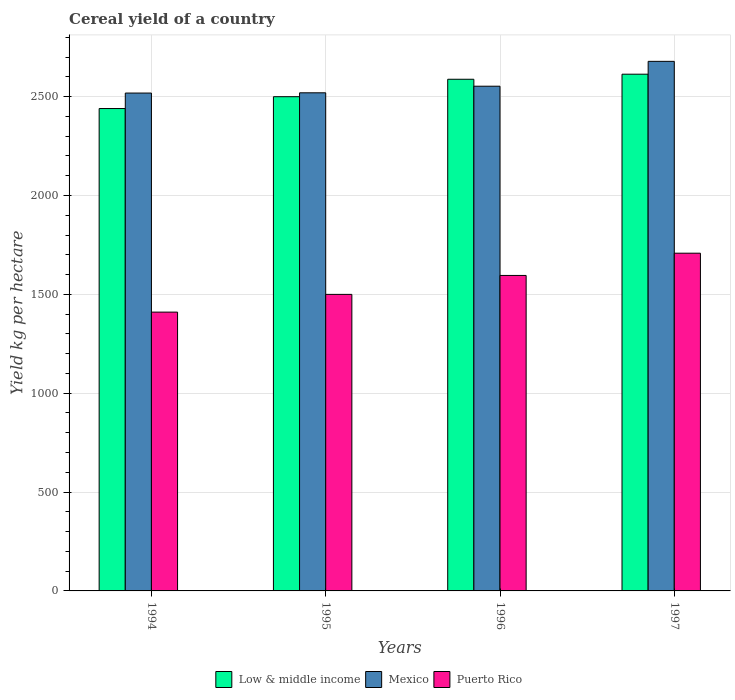How many different coloured bars are there?
Make the answer very short. 3. Are the number of bars per tick equal to the number of legend labels?
Make the answer very short. Yes. How many bars are there on the 2nd tick from the right?
Ensure brevity in your answer.  3. What is the label of the 2nd group of bars from the left?
Keep it short and to the point. 1995. In how many cases, is the number of bars for a given year not equal to the number of legend labels?
Keep it short and to the point. 0. What is the total cereal yield in Puerto Rico in 1995?
Ensure brevity in your answer.  1500. Across all years, what is the maximum total cereal yield in Puerto Rico?
Your answer should be compact. 1708.33. Across all years, what is the minimum total cereal yield in Puerto Rico?
Make the answer very short. 1410.26. What is the total total cereal yield in Low & middle income in the graph?
Make the answer very short. 1.01e+04. What is the difference between the total cereal yield in Mexico in 1995 and that in 1996?
Offer a terse response. -33.29. What is the difference between the total cereal yield in Mexico in 1996 and the total cereal yield in Puerto Rico in 1994?
Ensure brevity in your answer.  1142.67. What is the average total cereal yield in Puerto Rico per year?
Ensure brevity in your answer.  1553.58. In the year 1996, what is the difference between the total cereal yield in Puerto Rico and total cereal yield in Low & middle income?
Your answer should be very brief. -992.38. In how many years, is the total cereal yield in Puerto Rico greater than 400 kg per hectare?
Keep it short and to the point. 4. What is the ratio of the total cereal yield in Low & middle income in 1995 to that in 1996?
Your answer should be very brief. 0.97. What is the difference between the highest and the second highest total cereal yield in Mexico?
Your response must be concise. 125.77. What is the difference between the highest and the lowest total cereal yield in Low & middle income?
Your answer should be very brief. 173.73. In how many years, is the total cereal yield in Mexico greater than the average total cereal yield in Mexico taken over all years?
Give a very brief answer. 1. Is the sum of the total cereal yield in Low & middle income in 1994 and 1995 greater than the maximum total cereal yield in Mexico across all years?
Make the answer very short. Yes. What does the 3rd bar from the left in 1996 represents?
Provide a succinct answer. Puerto Rico. Is it the case that in every year, the sum of the total cereal yield in Mexico and total cereal yield in Low & middle income is greater than the total cereal yield in Puerto Rico?
Offer a very short reply. Yes. How many years are there in the graph?
Your answer should be compact. 4. Are the values on the major ticks of Y-axis written in scientific E-notation?
Ensure brevity in your answer.  No. Does the graph contain any zero values?
Provide a succinct answer. No. Does the graph contain grids?
Make the answer very short. Yes. What is the title of the graph?
Your answer should be compact. Cereal yield of a country. Does "Bosnia and Herzegovina" appear as one of the legend labels in the graph?
Offer a very short reply. No. What is the label or title of the Y-axis?
Ensure brevity in your answer.  Yield kg per hectare. What is the Yield kg per hectare of Low & middle income in 1994?
Make the answer very short. 2440. What is the Yield kg per hectare in Mexico in 1994?
Provide a short and direct response. 2518.31. What is the Yield kg per hectare in Puerto Rico in 1994?
Your answer should be compact. 1410.26. What is the Yield kg per hectare of Low & middle income in 1995?
Your answer should be very brief. 2499.92. What is the Yield kg per hectare of Mexico in 1995?
Your answer should be very brief. 2519.63. What is the Yield kg per hectare in Puerto Rico in 1995?
Offer a terse response. 1500. What is the Yield kg per hectare in Low & middle income in 1996?
Ensure brevity in your answer.  2588.12. What is the Yield kg per hectare of Mexico in 1996?
Provide a short and direct response. 2552.93. What is the Yield kg per hectare in Puerto Rico in 1996?
Your answer should be compact. 1595.74. What is the Yield kg per hectare in Low & middle income in 1997?
Provide a succinct answer. 2613.73. What is the Yield kg per hectare of Mexico in 1997?
Offer a terse response. 2678.7. What is the Yield kg per hectare of Puerto Rico in 1997?
Your answer should be very brief. 1708.33. Across all years, what is the maximum Yield kg per hectare of Low & middle income?
Give a very brief answer. 2613.73. Across all years, what is the maximum Yield kg per hectare in Mexico?
Keep it short and to the point. 2678.7. Across all years, what is the maximum Yield kg per hectare in Puerto Rico?
Make the answer very short. 1708.33. Across all years, what is the minimum Yield kg per hectare of Low & middle income?
Provide a succinct answer. 2440. Across all years, what is the minimum Yield kg per hectare in Mexico?
Your answer should be compact. 2518.31. Across all years, what is the minimum Yield kg per hectare of Puerto Rico?
Provide a short and direct response. 1410.26. What is the total Yield kg per hectare of Low & middle income in the graph?
Offer a terse response. 1.01e+04. What is the total Yield kg per hectare of Mexico in the graph?
Ensure brevity in your answer.  1.03e+04. What is the total Yield kg per hectare of Puerto Rico in the graph?
Make the answer very short. 6214.33. What is the difference between the Yield kg per hectare in Low & middle income in 1994 and that in 1995?
Your answer should be compact. -59.91. What is the difference between the Yield kg per hectare of Mexico in 1994 and that in 1995?
Provide a short and direct response. -1.32. What is the difference between the Yield kg per hectare of Puerto Rico in 1994 and that in 1995?
Provide a succinct answer. -89.74. What is the difference between the Yield kg per hectare of Low & middle income in 1994 and that in 1996?
Offer a terse response. -148.12. What is the difference between the Yield kg per hectare of Mexico in 1994 and that in 1996?
Your answer should be compact. -34.62. What is the difference between the Yield kg per hectare of Puerto Rico in 1994 and that in 1996?
Offer a very short reply. -185.49. What is the difference between the Yield kg per hectare in Low & middle income in 1994 and that in 1997?
Provide a succinct answer. -173.73. What is the difference between the Yield kg per hectare in Mexico in 1994 and that in 1997?
Provide a short and direct response. -160.39. What is the difference between the Yield kg per hectare of Puerto Rico in 1994 and that in 1997?
Offer a very short reply. -298.08. What is the difference between the Yield kg per hectare in Low & middle income in 1995 and that in 1996?
Your answer should be compact. -88.21. What is the difference between the Yield kg per hectare in Mexico in 1995 and that in 1996?
Make the answer very short. -33.29. What is the difference between the Yield kg per hectare of Puerto Rico in 1995 and that in 1996?
Offer a very short reply. -95.75. What is the difference between the Yield kg per hectare in Low & middle income in 1995 and that in 1997?
Make the answer very short. -113.82. What is the difference between the Yield kg per hectare of Mexico in 1995 and that in 1997?
Offer a terse response. -159.06. What is the difference between the Yield kg per hectare in Puerto Rico in 1995 and that in 1997?
Make the answer very short. -208.33. What is the difference between the Yield kg per hectare in Low & middle income in 1996 and that in 1997?
Your answer should be very brief. -25.61. What is the difference between the Yield kg per hectare of Mexico in 1996 and that in 1997?
Keep it short and to the point. -125.77. What is the difference between the Yield kg per hectare of Puerto Rico in 1996 and that in 1997?
Provide a short and direct response. -112.59. What is the difference between the Yield kg per hectare in Low & middle income in 1994 and the Yield kg per hectare in Mexico in 1995?
Provide a succinct answer. -79.63. What is the difference between the Yield kg per hectare in Low & middle income in 1994 and the Yield kg per hectare in Puerto Rico in 1995?
Make the answer very short. 940. What is the difference between the Yield kg per hectare of Mexico in 1994 and the Yield kg per hectare of Puerto Rico in 1995?
Keep it short and to the point. 1018.31. What is the difference between the Yield kg per hectare of Low & middle income in 1994 and the Yield kg per hectare of Mexico in 1996?
Provide a succinct answer. -112.92. What is the difference between the Yield kg per hectare of Low & middle income in 1994 and the Yield kg per hectare of Puerto Rico in 1996?
Your answer should be compact. 844.26. What is the difference between the Yield kg per hectare of Mexico in 1994 and the Yield kg per hectare of Puerto Rico in 1996?
Offer a very short reply. 922.57. What is the difference between the Yield kg per hectare of Low & middle income in 1994 and the Yield kg per hectare of Mexico in 1997?
Your answer should be compact. -238.69. What is the difference between the Yield kg per hectare in Low & middle income in 1994 and the Yield kg per hectare in Puerto Rico in 1997?
Provide a short and direct response. 731.67. What is the difference between the Yield kg per hectare in Mexico in 1994 and the Yield kg per hectare in Puerto Rico in 1997?
Offer a terse response. 809.98. What is the difference between the Yield kg per hectare of Low & middle income in 1995 and the Yield kg per hectare of Mexico in 1996?
Your answer should be very brief. -53.01. What is the difference between the Yield kg per hectare of Low & middle income in 1995 and the Yield kg per hectare of Puerto Rico in 1996?
Provide a succinct answer. 904.17. What is the difference between the Yield kg per hectare in Mexico in 1995 and the Yield kg per hectare in Puerto Rico in 1996?
Keep it short and to the point. 923.89. What is the difference between the Yield kg per hectare of Low & middle income in 1995 and the Yield kg per hectare of Mexico in 1997?
Ensure brevity in your answer.  -178.78. What is the difference between the Yield kg per hectare in Low & middle income in 1995 and the Yield kg per hectare in Puerto Rico in 1997?
Offer a very short reply. 791.58. What is the difference between the Yield kg per hectare of Mexico in 1995 and the Yield kg per hectare of Puerto Rico in 1997?
Offer a terse response. 811.3. What is the difference between the Yield kg per hectare in Low & middle income in 1996 and the Yield kg per hectare in Mexico in 1997?
Give a very brief answer. -90.57. What is the difference between the Yield kg per hectare in Low & middle income in 1996 and the Yield kg per hectare in Puerto Rico in 1997?
Your answer should be very brief. 879.79. What is the difference between the Yield kg per hectare of Mexico in 1996 and the Yield kg per hectare of Puerto Rico in 1997?
Provide a succinct answer. 844.59. What is the average Yield kg per hectare in Low & middle income per year?
Your answer should be compact. 2535.44. What is the average Yield kg per hectare of Mexico per year?
Your answer should be compact. 2567.39. What is the average Yield kg per hectare of Puerto Rico per year?
Ensure brevity in your answer.  1553.58. In the year 1994, what is the difference between the Yield kg per hectare in Low & middle income and Yield kg per hectare in Mexico?
Offer a terse response. -78.31. In the year 1994, what is the difference between the Yield kg per hectare of Low & middle income and Yield kg per hectare of Puerto Rico?
Make the answer very short. 1029.75. In the year 1994, what is the difference between the Yield kg per hectare of Mexico and Yield kg per hectare of Puerto Rico?
Make the answer very short. 1108.05. In the year 1995, what is the difference between the Yield kg per hectare of Low & middle income and Yield kg per hectare of Mexico?
Make the answer very short. -19.72. In the year 1995, what is the difference between the Yield kg per hectare of Low & middle income and Yield kg per hectare of Puerto Rico?
Offer a terse response. 999.92. In the year 1995, what is the difference between the Yield kg per hectare of Mexico and Yield kg per hectare of Puerto Rico?
Your answer should be compact. 1019.63. In the year 1996, what is the difference between the Yield kg per hectare of Low & middle income and Yield kg per hectare of Mexico?
Keep it short and to the point. 35.2. In the year 1996, what is the difference between the Yield kg per hectare of Low & middle income and Yield kg per hectare of Puerto Rico?
Give a very brief answer. 992.38. In the year 1996, what is the difference between the Yield kg per hectare of Mexico and Yield kg per hectare of Puerto Rico?
Offer a terse response. 957.18. In the year 1997, what is the difference between the Yield kg per hectare in Low & middle income and Yield kg per hectare in Mexico?
Your answer should be very brief. -64.96. In the year 1997, what is the difference between the Yield kg per hectare in Low & middle income and Yield kg per hectare in Puerto Rico?
Make the answer very short. 905.4. In the year 1997, what is the difference between the Yield kg per hectare of Mexico and Yield kg per hectare of Puerto Rico?
Offer a terse response. 970.36. What is the ratio of the Yield kg per hectare of Mexico in 1994 to that in 1995?
Your response must be concise. 1. What is the ratio of the Yield kg per hectare in Puerto Rico in 1994 to that in 1995?
Keep it short and to the point. 0.94. What is the ratio of the Yield kg per hectare in Low & middle income in 1994 to that in 1996?
Provide a succinct answer. 0.94. What is the ratio of the Yield kg per hectare in Mexico in 1994 to that in 1996?
Offer a terse response. 0.99. What is the ratio of the Yield kg per hectare of Puerto Rico in 1994 to that in 1996?
Your answer should be compact. 0.88. What is the ratio of the Yield kg per hectare of Low & middle income in 1994 to that in 1997?
Keep it short and to the point. 0.93. What is the ratio of the Yield kg per hectare of Mexico in 1994 to that in 1997?
Keep it short and to the point. 0.94. What is the ratio of the Yield kg per hectare in Puerto Rico in 1994 to that in 1997?
Make the answer very short. 0.83. What is the ratio of the Yield kg per hectare of Low & middle income in 1995 to that in 1996?
Your answer should be very brief. 0.97. What is the ratio of the Yield kg per hectare of Mexico in 1995 to that in 1996?
Offer a terse response. 0.99. What is the ratio of the Yield kg per hectare of Puerto Rico in 1995 to that in 1996?
Your answer should be very brief. 0.94. What is the ratio of the Yield kg per hectare of Low & middle income in 1995 to that in 1997?
Provide a short and direct response. 0.96. What is the ratio of the Yield kg per hectare of Mexico in 1995 to that in 1997?
Make the answer very short. 0.94. What is the ratio of the Yield kg per hectare in Puerto Rico in 1995 to that in 1997?
Make the answer very short. 0.88. What is the ratio of the Yield kg per hectare of Low & middle income in 1996 to that in 1997?
Make the answer very short. 0.99. What is the ratio of the Yield kg per hectare in Mexico in 1996 to that in 1997?
Provide a succinct answer. 0.95. What is the ratio of the Yield kg per hectare in Puerto Rico in 1996 to that in 1997?
Your answer should be compact. 0.93. What is the difference between the highest and the second highest Yield kg per hectare of Low & middle income?
Make the answer very short. 25.61. What is the difference between the highest and the second highest Yield kg per hectare in Mexico?
Provide a succinct answer. 125.77. What is the difference between the highest and the second highest Yield kg per hectare in Puerto Rico?
Your answer should be compact. 112.59. What is the difference between the highest and the lowest Yield kg per hectare in Low & middle income?
Ensure brevity in your answer.  173.73. What is the difference between the highest and the lowest Yield kg per hectare in Mexico?
Provide a succinct answer. 160.39. What is the difference between the highest and the lowest Yield kg per hectare of Puerto Rico?
Your response must be concise. 298.08. 